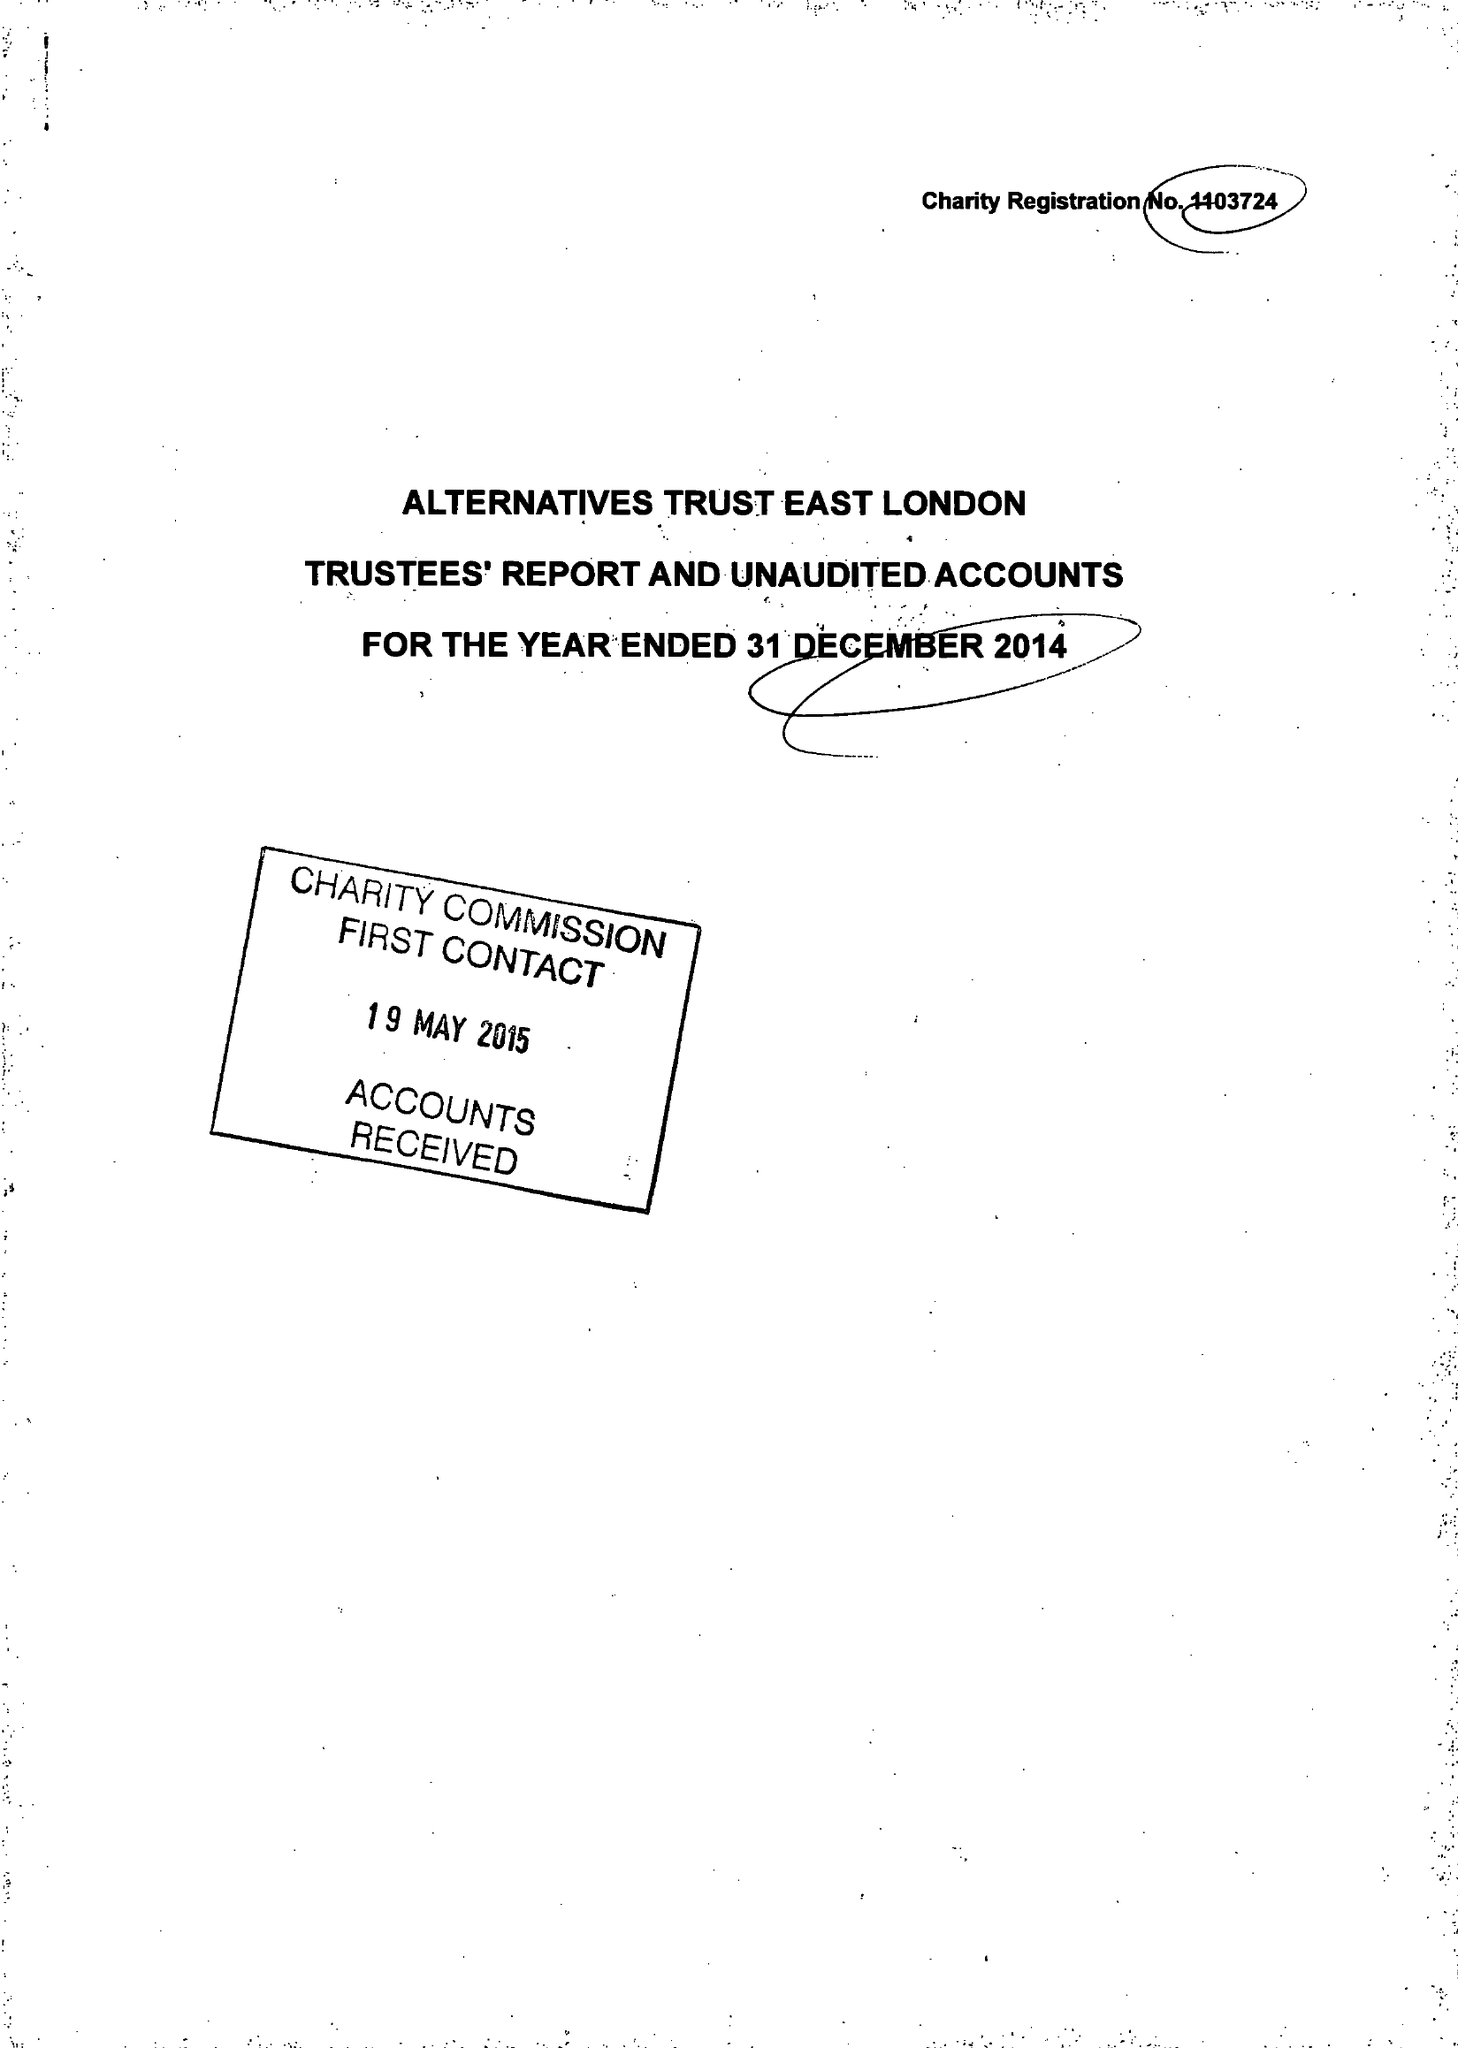What is the value for the spending_annually_in_british_pounds?
Answer the question using a single word or phrase. 105267.00 